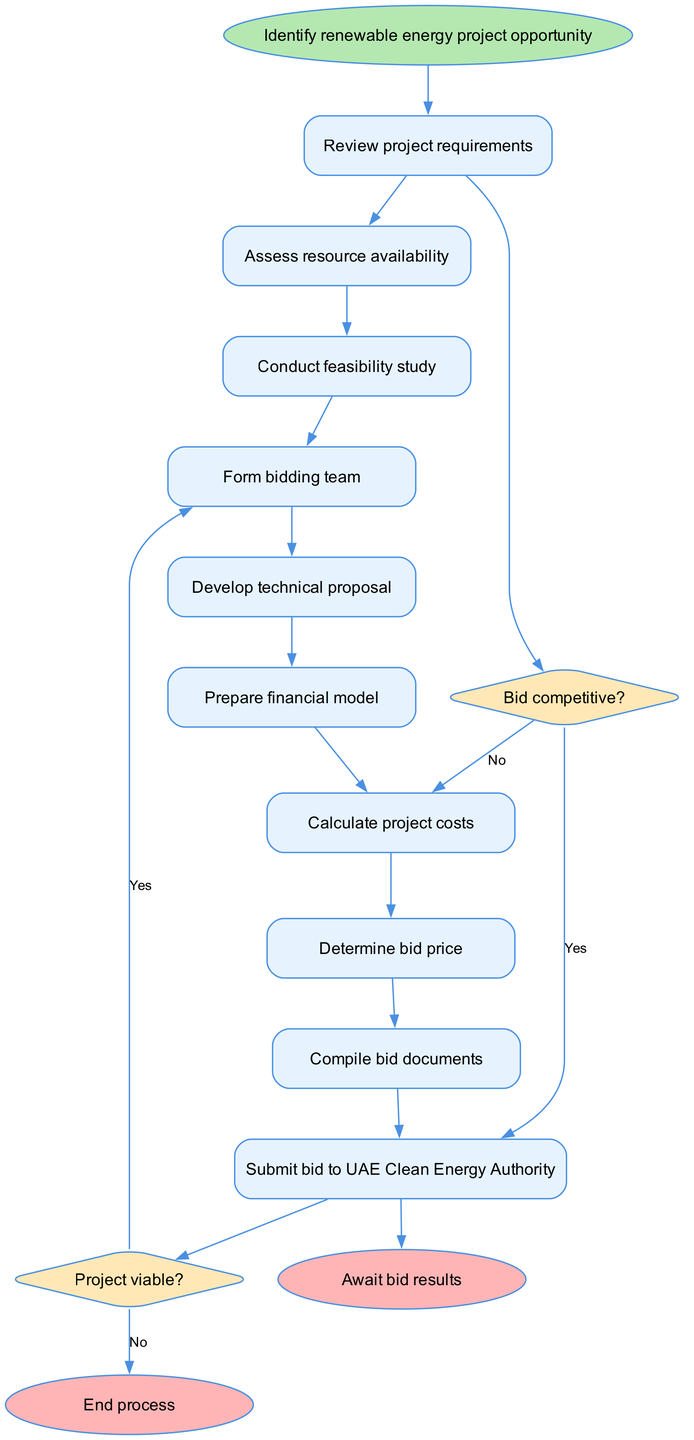What is the first step in the workflow? The first step is clearly stated at the start of the flowchart as "Identify renewable energy project opportunity." This is indicated in the starting node of the diagram.
Answer: Identify renewable energy project opportunity How many decision nodes are present in the diagram? By examining the diagram, we can count the decision nodes, which are represented by diamonds. There are two decision nodes labeled "Project viable?" and "Bid competitive?".
Answer: 2 What action follows the feasibility study? According to the flow of the diagram, after conducting the feasibility study, the next action is to "Form bidding team." This is a direct transition from one node to the next in the workflow.
Answer: Form bidding team If the project is not viable, what is the outcome? The diagram specifies that if the answer to the decision "Project viable?" is no, the workflow ends the process immediately. This is indicated by the connection leading to the "End process" node.
Answer: End process What happens if the bid is not competitive? If the bid is determined not to be competitive after the corresponding decision node, the workflow indicates that the next step is to "Revise bid." This shows the feedback loop to improve the bid proposal.
Answer: Revise bid How many total actions or nodes are outlined in the workflow excluding decisions? Counting only the process nodes (not including the decision nodes), there are 9 actions outlined in the workflow, which detail the sequential steps from identification to submission of the bid.
Answer: 9 What is the final step in the process? The final step in the diagram is represented by the end node, which states "Await bid results." This concludes the bidding workflow process.
Answer: Await bid results What decision follows assessing resource availability? After assessing resource availability, the workflow leads directly to the decision node "Project viable?". This indicates a critical evaluation before moving to the next phase of the bidding process.
Answer: Project viable? 